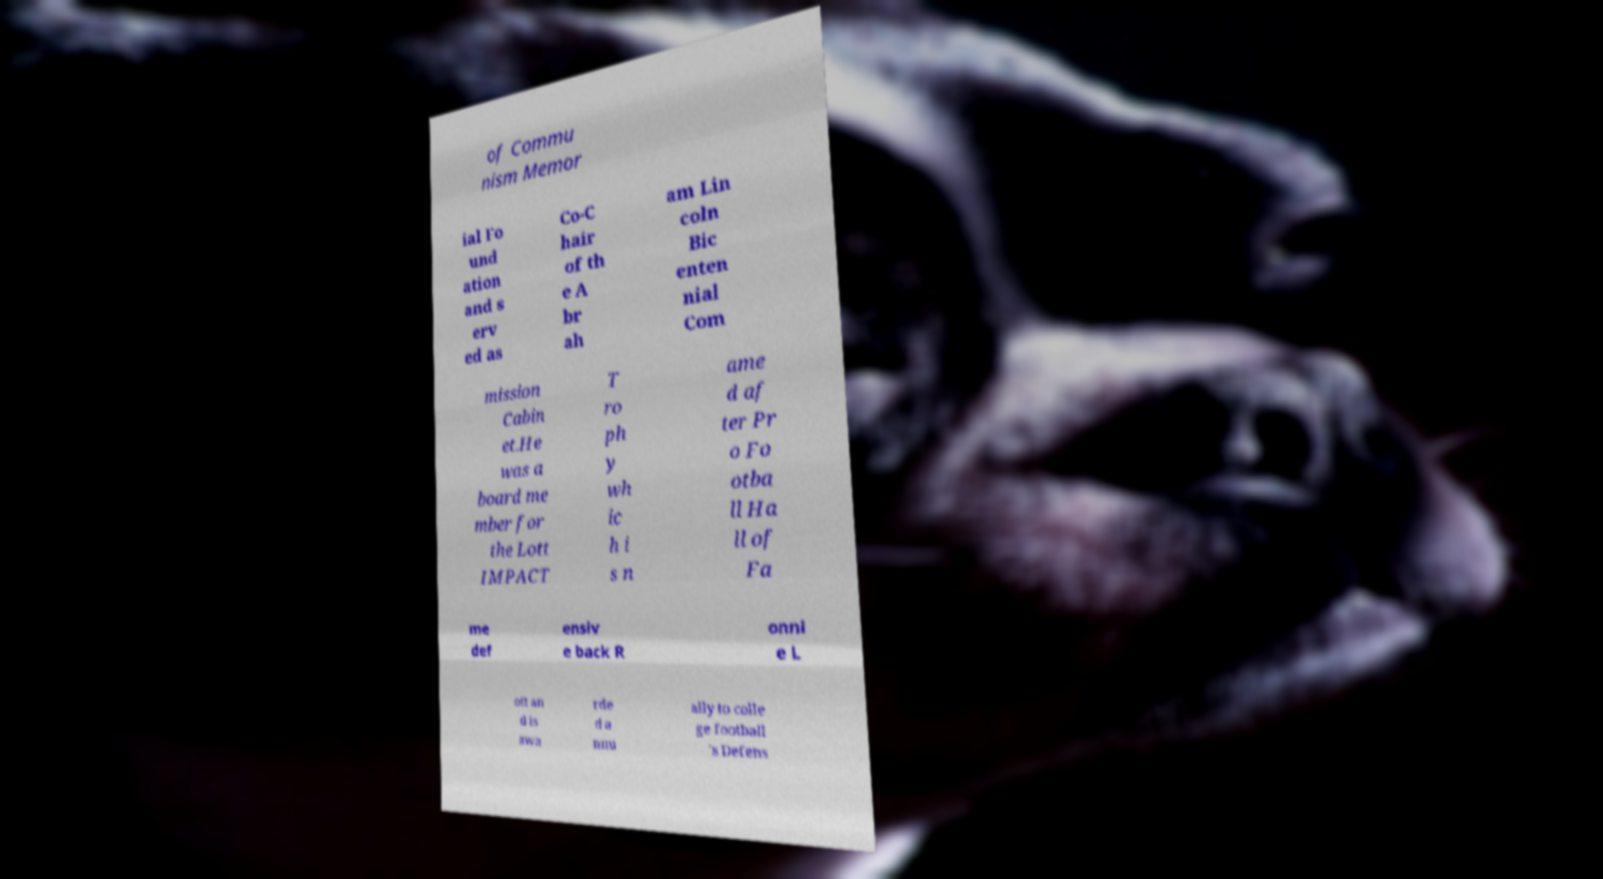I need the written content from this picture converted into text. Can you do that? of Commu nism Memor ial Fo und ation and s erv ed as Co-C hair of th e A br ah am Lin coln Bic enten nial Com mission Cabin et.He was a board me mber for the Lott IMPACT T ro ph y wh ic h i s n ame d af ter Pr o Fo otba ll Ha ll of Fa me def ensiv e back R onni e L ott an d is awa rde d a nnu ally to colle ge football 's Defens 